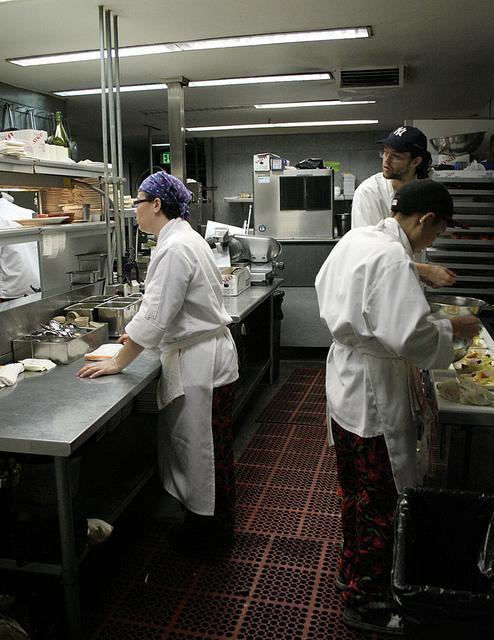How many people are there?
Give a very brief answer. 4. How many umbrellas are there?
Give a very brief answer. 0. 